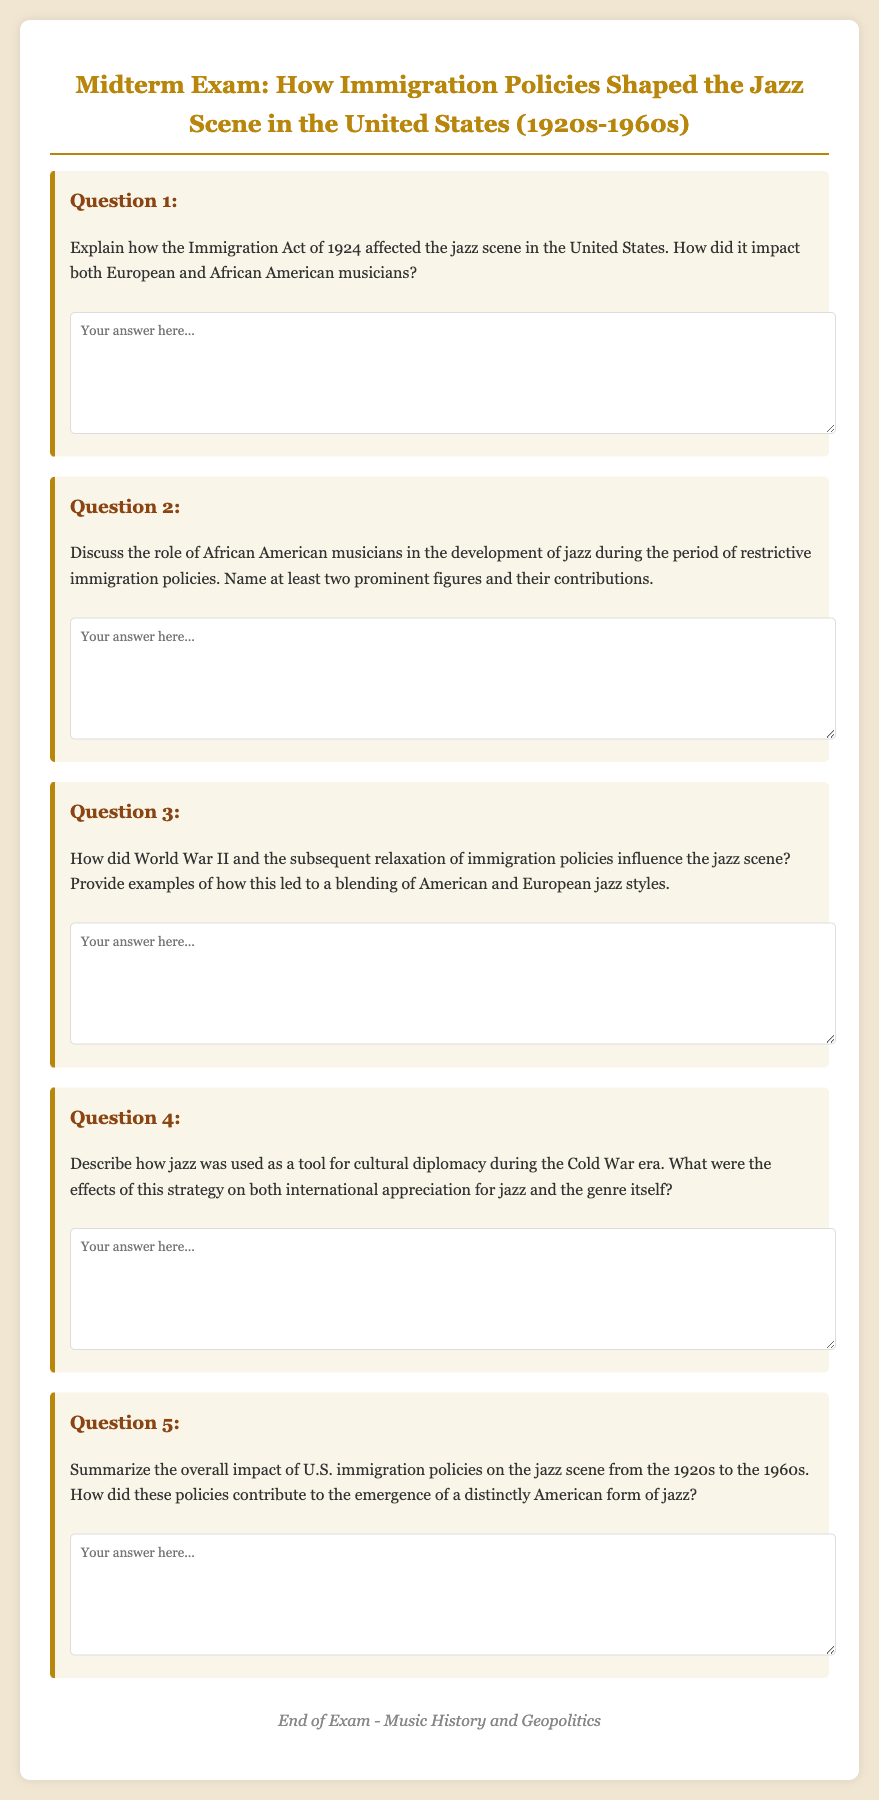What immigration policy is discussed in the document? The document mentions the Immigration Act of 1924, which affected the jazz scene in the United States.
Answer: Immigration Act of 1924 Who were two prominent African American musicians mentioned in the document? The document prompts an answer about at least two African American musicians who contributed to the development of jazz.
Answer: (Any two names) What major global event is referenced in relation to the relaxation of immigration policies? The document discusses World War II as a significant influence on immigration policies and the jazz scene.
Answer: World War II What era is described as using jazz for cultural diplomacy? The document refers to the Cold War era concerning jazz's role in cultural diplomacy.
Answer: Cold War What is the purpose of the midterm exam based on the document? The midterm exam is designed to assess understanding of how immigration policies shaped the jazz scene in the United States.
Answer: To assess understanding What is the time frame discussed in the document for the jazz scene? The document specifies that the midterm exam covers the jazz scene from the 1920s to the 1960s.
Answer: 1920s to 1960s How did restrictive immigration policies influence the jazz scene? The document inquires about the effects of restrictive immigration policies on the development of jazz and its musicians.
Answer: (Specific effects described in responses) 